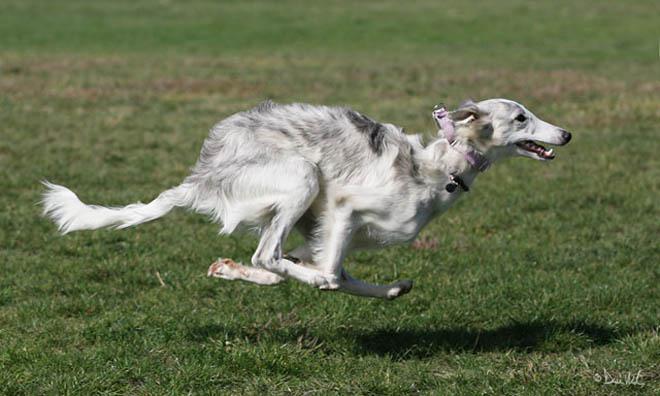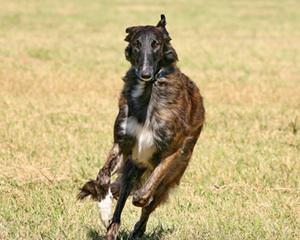The first image is the image on the left, the second image is the image on the right. For the images shown, is this caption "Each image includes bounding hounds, and the right image shows a hound with its body leaning to the right as it runs forward." true? Answer yes or no. Yes. The first image is the image on the left, the second image is the image on the right. Analyze the images presented: Is the assertion "At least one dog has its front paws off the ground." valid? Answer yes or no. Yes. 